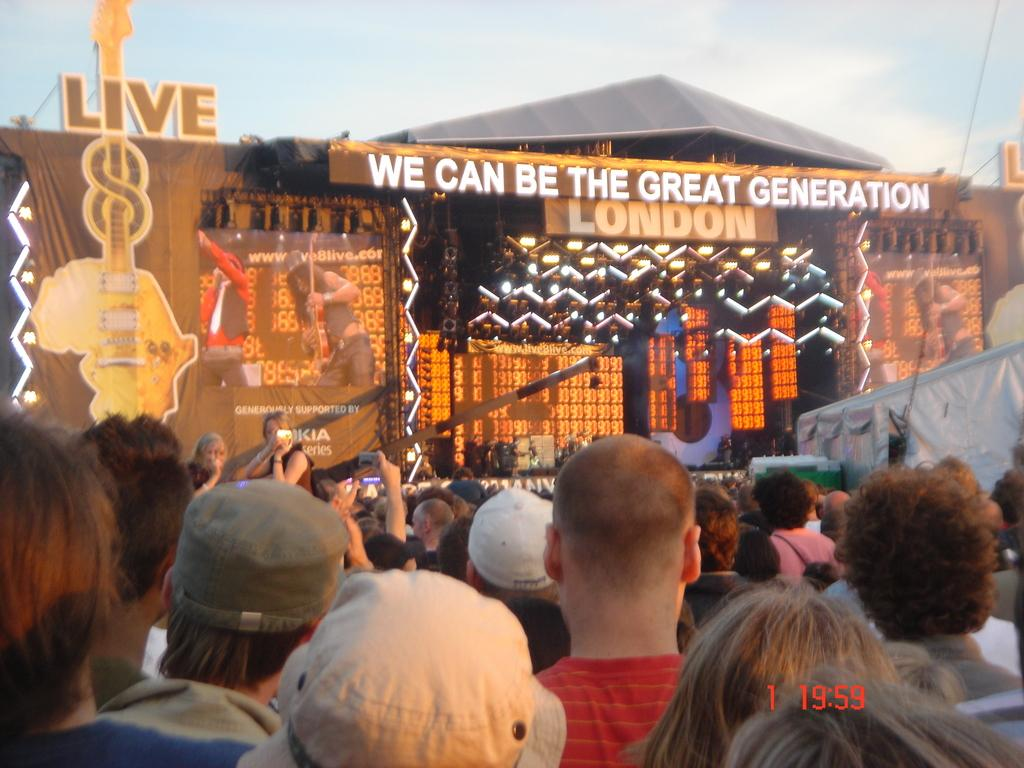How many people are visible in the image? There are many persons in the image. What event is taking place in the image? It appears to be a concert. What is located in the front of the image? There is a dais in the front of the image. What can be seen on the dais? Banners are present on the dais. Is there any signage visible in the image? Yes, there is a name board in the image. How many bats are flying around the concert in the image? There are no bats visible in the image; it is a concert with people and a dais. How many legs are visible in the image? It is difficult to count individual legs in the image due to the large number of people present. 